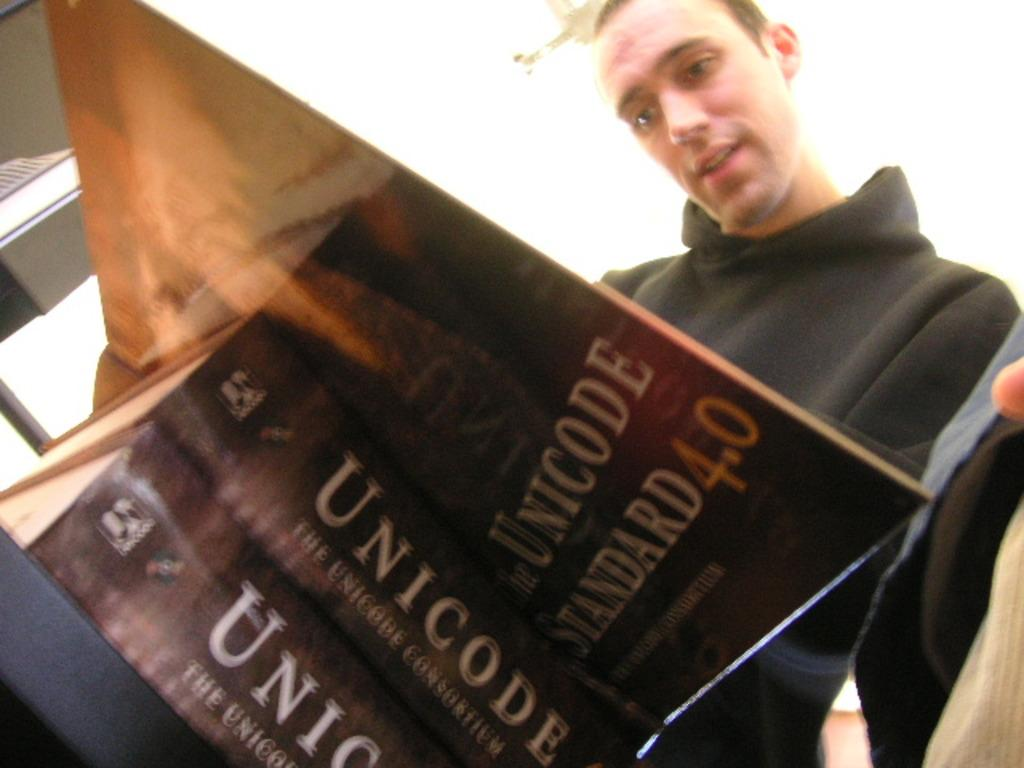<image>
Write a terse but informative summary of the picture. A man in a black hoodie looking down at an open book titled Unicode Standard 4.0 on top of a stack of two of the same book 